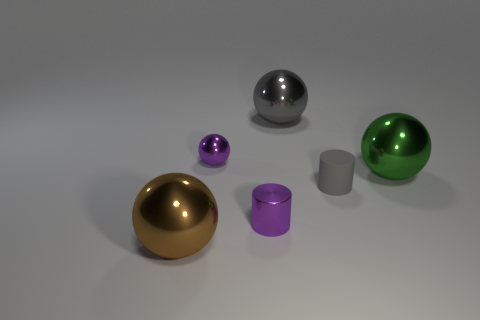Add 3 big gray shiny cylinders. How many objects exist? 9 Subtract all purple metallic balls. How many balls are left? 3 Subtract all gray spheres. How many spheres are left? 3 Subtract all cylinders. How many objects are left? 4 Subtract all large balls. Subtract all big cyan matte cubes. How many objects are left? 3 Add 1 purple cylinders. How many purple cylinders are left? 2 Add 2 spheres. How many spheres exist? 6 Subtract 1 purple cylinders. How many objects are left? 5 Subtract all red balls. Subtract all green cylinders. How many balls are left? 4 